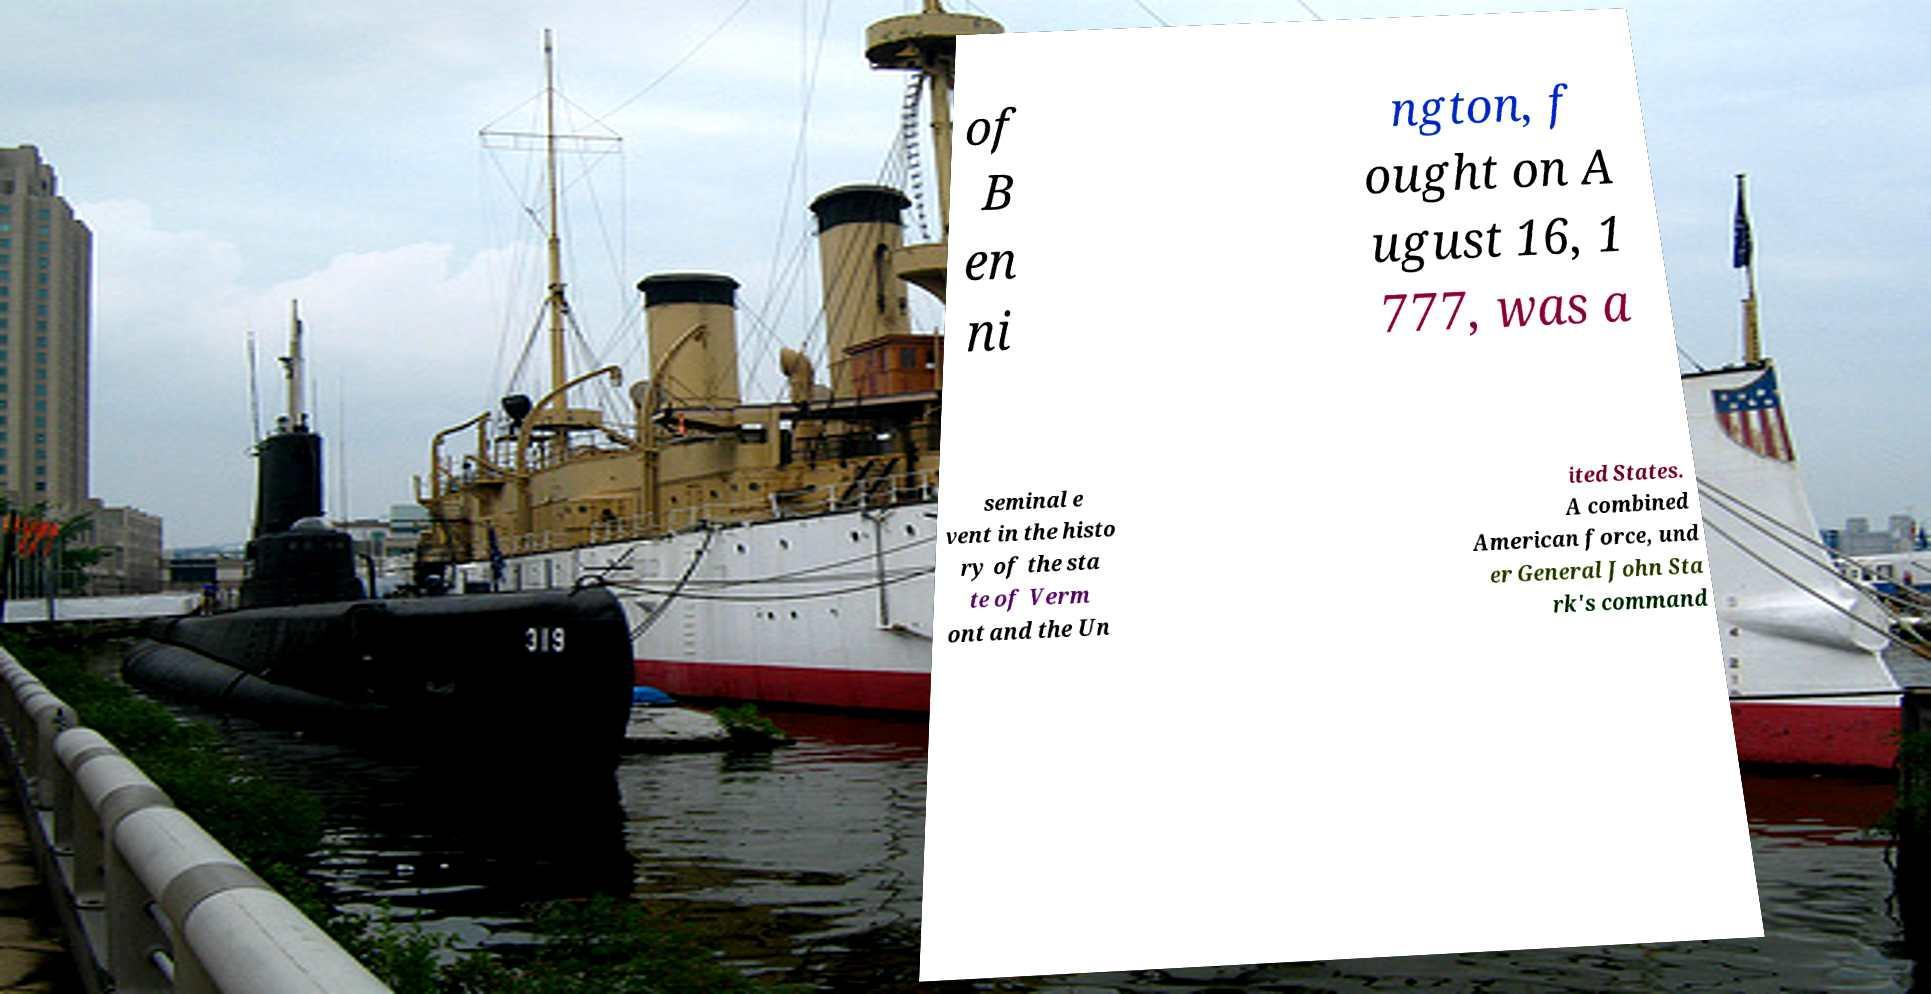Please read and relay the text visible in this image. What does it say? of B en ni ngton, f ought on A ugust 16, 1 777, was a seminal e vent in the histo ry of the sta te of Verm ont and the Un ited States. A combined American force, und er General John Sta rk's command 